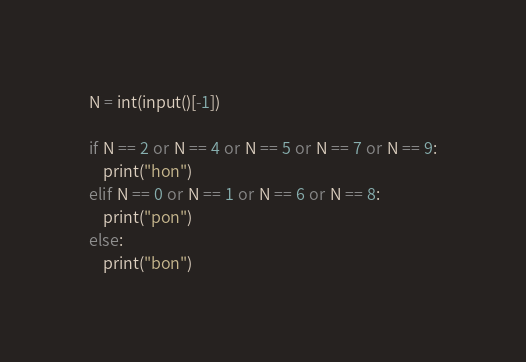Convert code to text. <code><loc_0><loc_0><loc_500><loc_500><_Python_>N = int(input()[-1])

if N == 2 or N == 4 or N == 5 or N == 7 or N == 9:
    print("hon")
elif N == 0 or N == 1 or N == 6 or N == 8:
    print("pon")
else:
    print("bon")</code> 